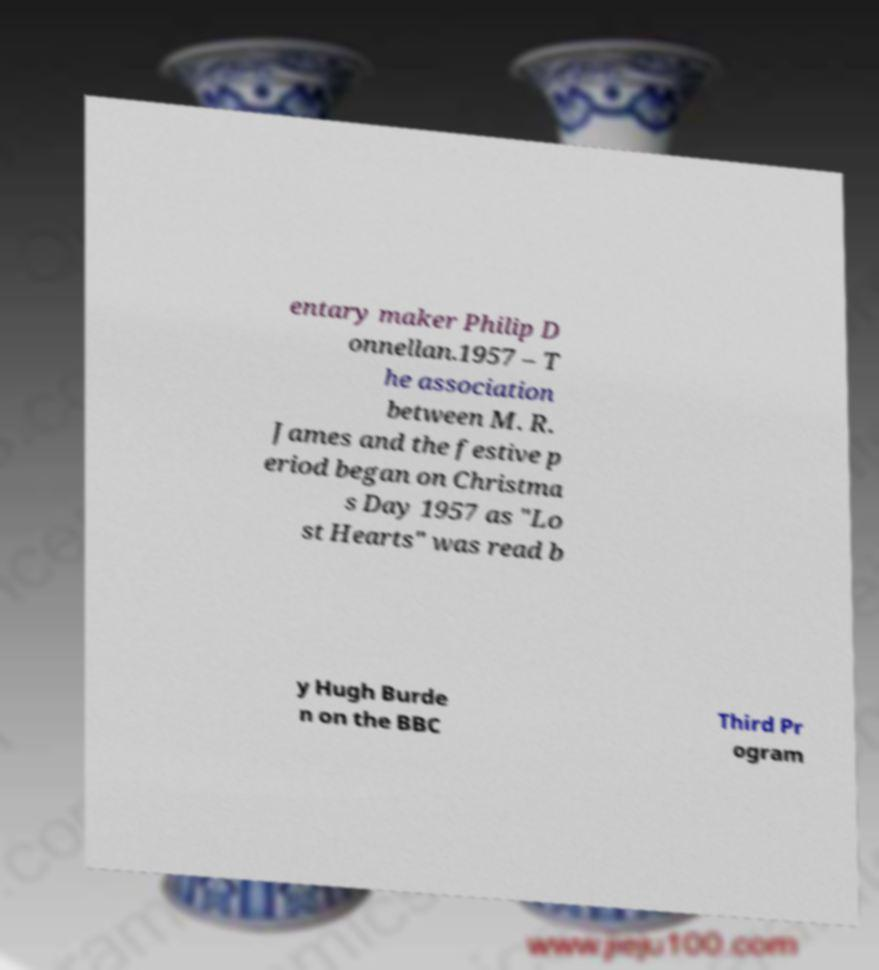Could you extract and type out the text from this image? entary maker Philip D onnellan.1957 – T he association between M. R. James and the festive p eriod began on Christma s Day 1957 as "Lo st Hearts" was read b y Hugh Burde n on the BBC Third Pr ogram 